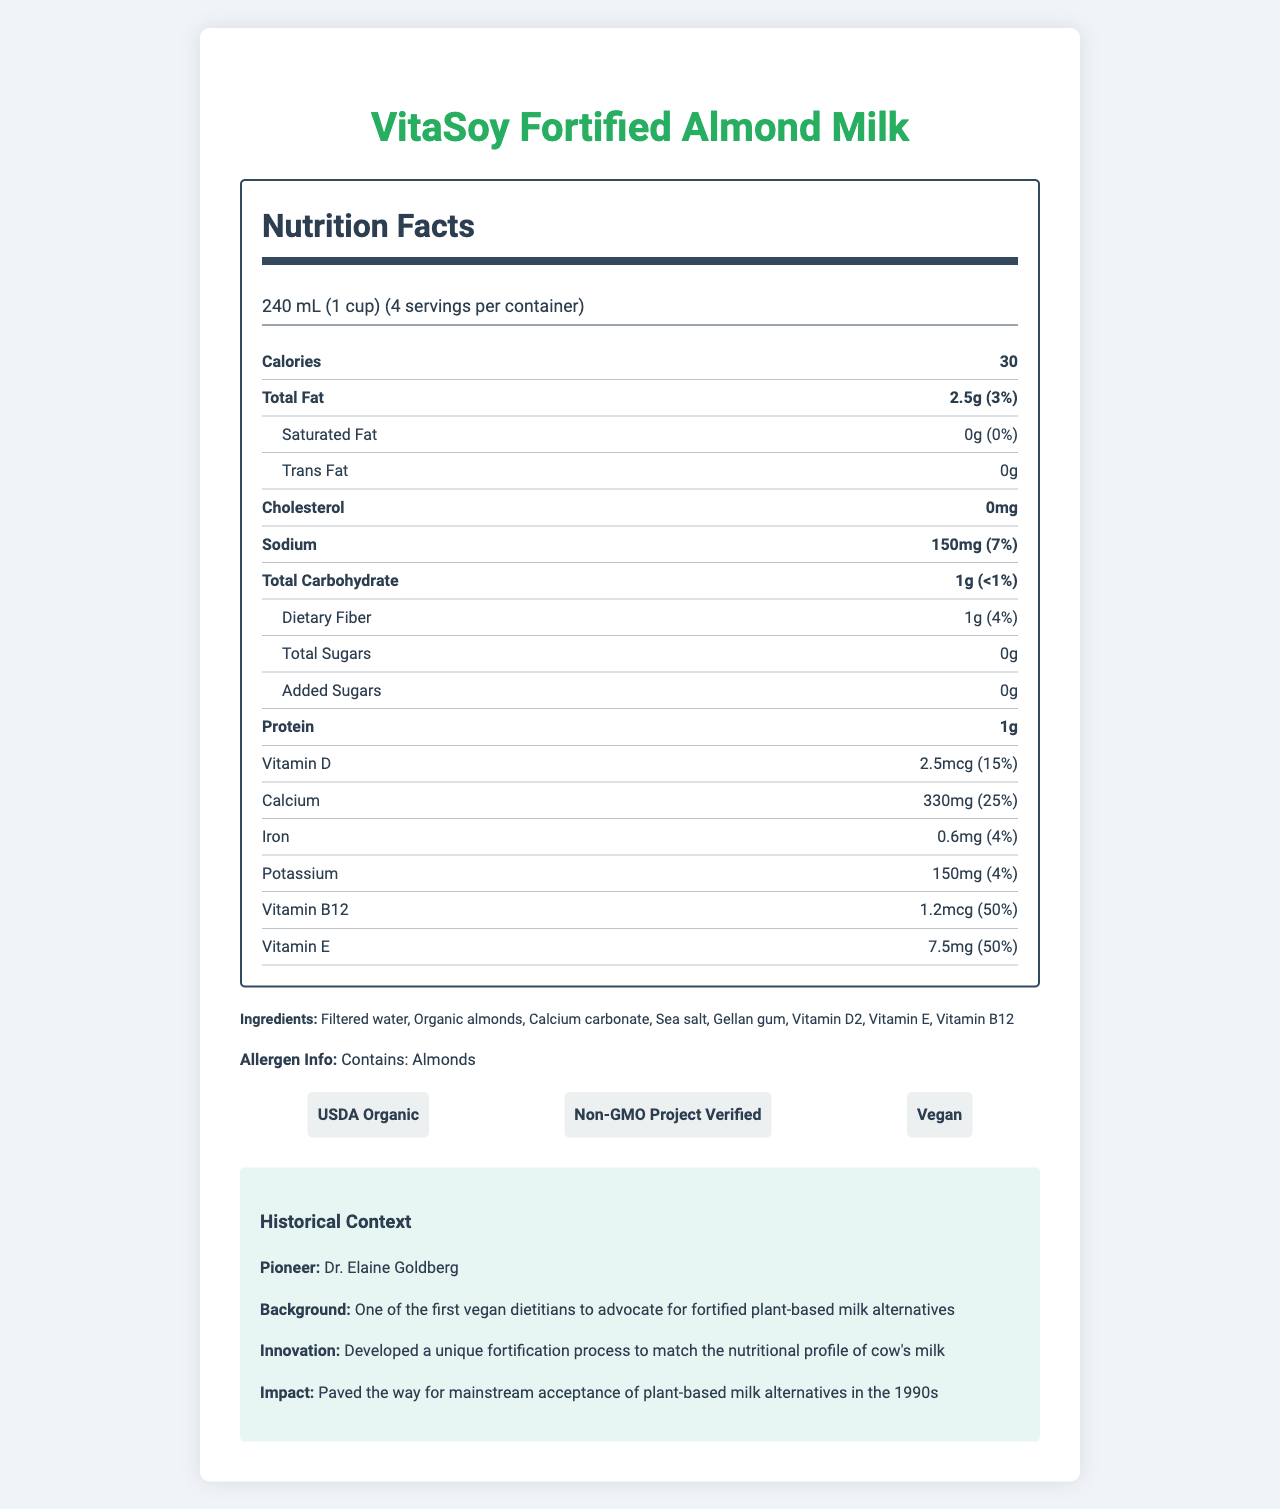what is the serving size? The serving size is clearly listed at the beginning of the nutrition label: "240 mL (1 cup)".
Answer: 240 mL (1 cup) how many calories are in one serving? The number of calories per serving is indicated in the bold label under "Nutrition Facts": "Calories 30".
Answer: 30 what is the total fat content per serving? The document states under "Total Fat" that each serving contains "2.5g (3%)".
Answer: 2.5g (3%) what is the sodium content per serving? Under "Sodium" in the nutrition facts, the content is "150mg (7%)" per serving.
Answer: 150mg (7%) what vitamins are included in this milk alternative? The vitamins listed in the nutrition facts include: Vitamin D, Vitamin B12, and Vitamin E.
Answer: Vitamin D, Vitamin B12, Vitamin E how many grams of protein does one serving contain? Under "Protein" in the nutrition facts, it states "1g".
Answer: 1g which of the following certifications does VitaSoy Fortified Almond Milk have? I. USDA Organic II. Non-GMO Project Verified III. Fair Trade A. I only B. I and II only C. I, II, and III The certifications listed are "USDA Organic" and "Non-GMO Project Verified"; there is no mention of Fair Trade certification.
Answer: B which nutrient has the highest daily value percentage? A. Calcium B. Vitamin B12 C. Vitamin E D. Sodium Vitamin B12 has the highest daily value percentage listed at 50%.
Answer: B does this product contain any cholesterol? The label under "Cholesterol" shows "0mg", indicating no cholesterol.
Answer: No summarize the main idea of the document. The document lays out the nutritional content of the milk alternative, mentions its developer, and highlights its historical significance and certifications.
Answer: The document provides the nutritional facts of VitaSoy Fortified Almond Milk, developed by Dr. Elaine Goldberg in 1987. It includes details on serving size, calories, fat, vitamins, and minerals. It also lists ingredients, allergen information, certifications, and historical context. who pioneered the development of this plant-based milk alternative? The historical context section identifies Dr. Elaine Goldberg as the pioneer.
Answer: Dr. Elaine Goldberg when was VitaSoy Fortified Almond Milk introduced? The historical context states that the product was introduced in 1987.
Answer: 1987 what is the total carbohydrate content per serving? Under "Total Carbohydrate" in the nutrition facts, it states "1g (<1%)".
Answer: 1g (<1%) which ingredient is not listed in the ingredients section? A. Filtered water B. Organic almonds C. Calcium carbonate D. Cane sugar The ingredients listed are: Filtered water, Organic almonds, Calcium carbonate, Sea salt, Gellan gum, Vitamin D2, Vitamin E, Vitamin B12. Cane sugar is not listed.
Answer: D is the product fortified to match the nutritional profile of cow's milk? The historical context states that the product was developed to match the nutritional profile of cow’s milk.
Answer: Yes what is the daily value percentage of iron per serving? Under "Iron" in the nutrition facts, it states the daily value is 4%.
Answer: 4% who wrote the historical context section? The document does not provide the author of the historical context section; it only mentions the content itself.
Answer: Not enough information what is the impact mentioned for this fortified milk alternative? The historical context section explains that this product paved the way for mainstream acceptance of plant-based milk alternatives in the 1990s.
Answer: Paved the way for mainstream acceptance of plant-based milk alternatives in the 1990s 